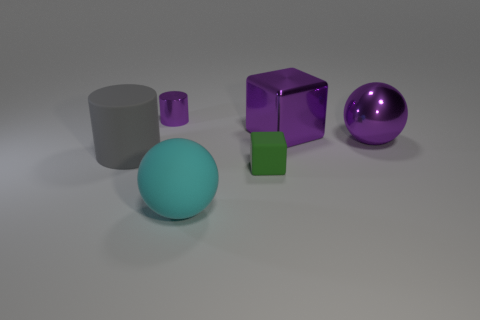There is a big gray matte thing; how many objects are behind it?
Give a very brief answer. 3. The large object that is the same material as the purple sphere is what color?
Ensure brevity in your answer.  Purple. Do the large gray matte thing and the small rubber object have the same shape?
Your answer should be compact. No. What number of purple objects are behind the big purple sphere and right of the tiny purple shiny cylinder?
Ensure brevity in your answer.  1. How many matte things are either blue cylinders or big objects?
Your answer should be very brief. 2. There is a metal cube behind the large thing that is to the left of the cyan matte sphere; what size is it?
Provide a short and direct response. Large. Is there a large cyan ball in front of the ball right of the ball that is left of the small cube?
Keep it short and to the point. Yes. Do the tiny object that is on the right side of the shiny cylinder and the large thing left of the small cylinder have the same material?
Offer a terse response. Yes. How many things are big cyan things or matte cubes on the right side of the rubber cylinder?
Offer a terse response. 2. How many purple objects are the same shape as the gray matte thing?
Provide a succinct answer. 1. 